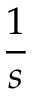Convert formula to latex. <formula><loc_0><loc_0><loc_500><loc_500>\frac { 1 } { s }</formula> 